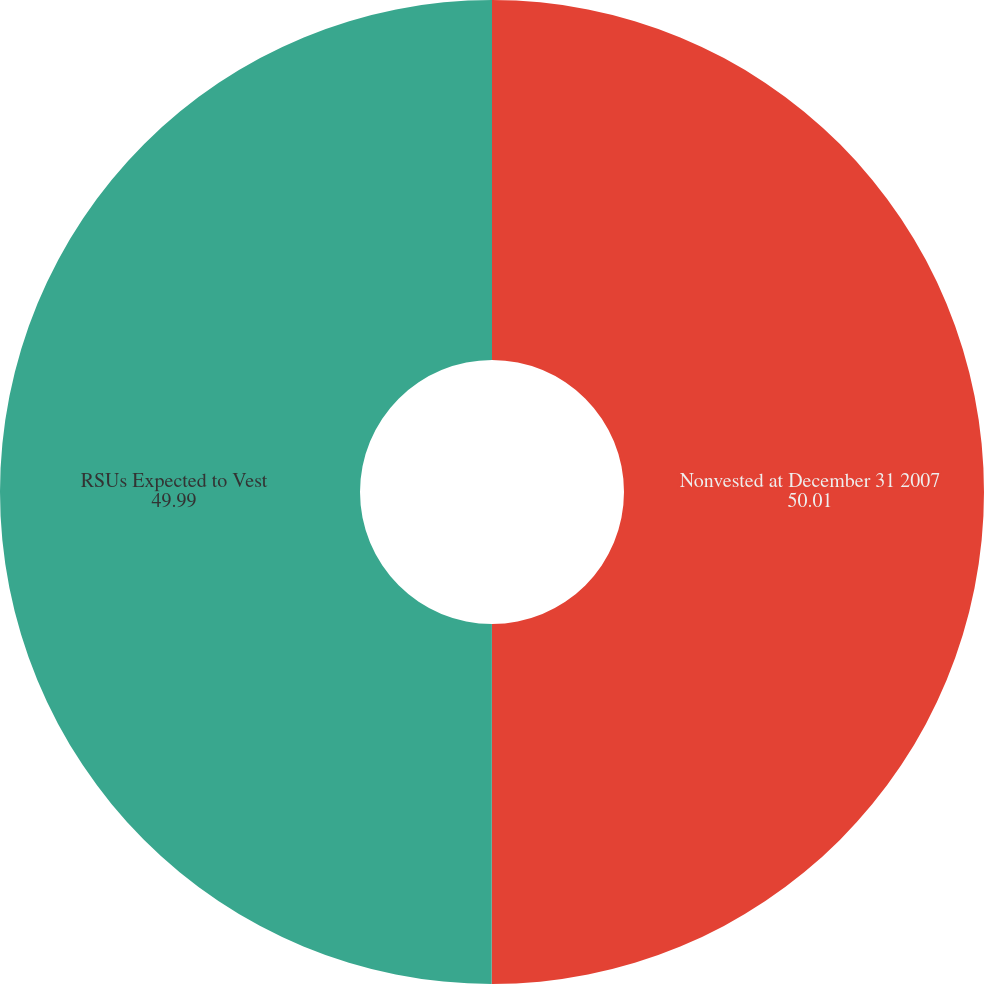Convert chart. <chart><loc_0><loc_0><loc_500><loc_500><pie_chart><fcel>Nonvested at December 31 2007<fcel>RSUs Expected to Vest<nl><fcel>50.01%<fcel>49.99%<nl></chart> 